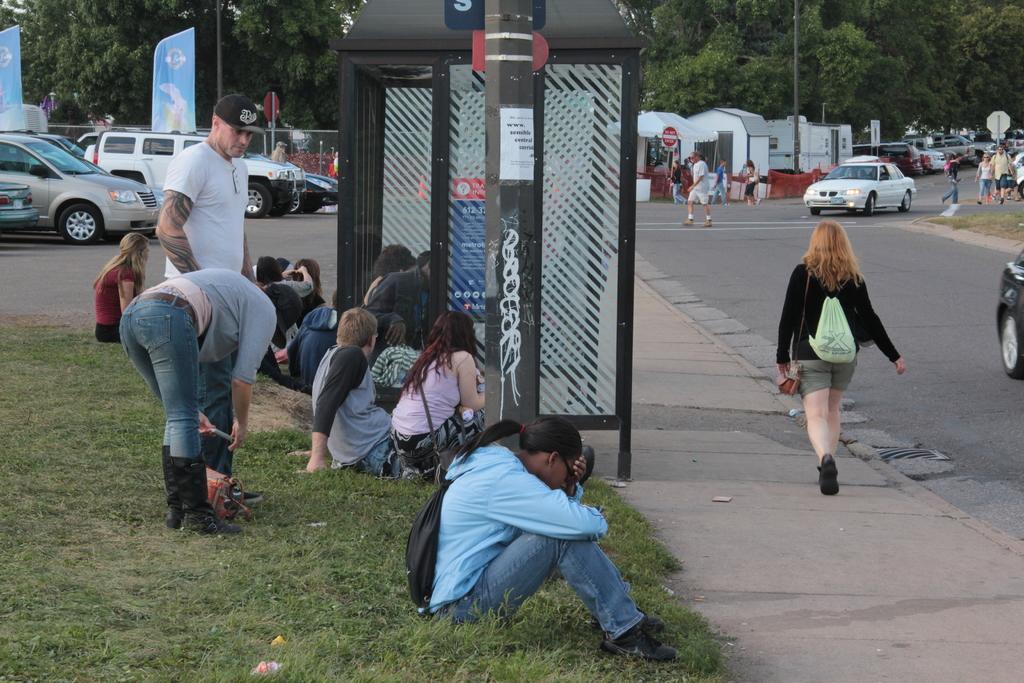Could you give a brief overview of what you see in this image? At the center of the image there is a metal structure, in front of that there is a pole and there are a few people sitting and standing on the surface of the grass, beside them there are few vehicles parked and few are moving on the road, there are a few people standing and walking on the road, there are few stalls, poles and banners. In the background there is the sky. 